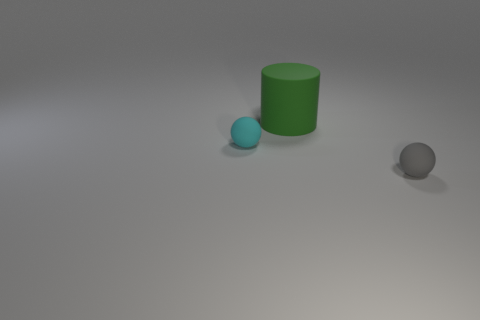Add 2 tiny cyan objects. How many objects exist? 5 Subtract all cylinders. How many objects are left? 2 Add 1 tiny cyan matte spheres. How many tiny cyan matte spheres are left? 2 Add 3 green cylinders. How many green cylinders exist? 4 Subtract 0 purple cylinders. How many objects are left? 3 Subtract all small gray balls. Subtract all green rubber cylinders. How many objects are left? 1 